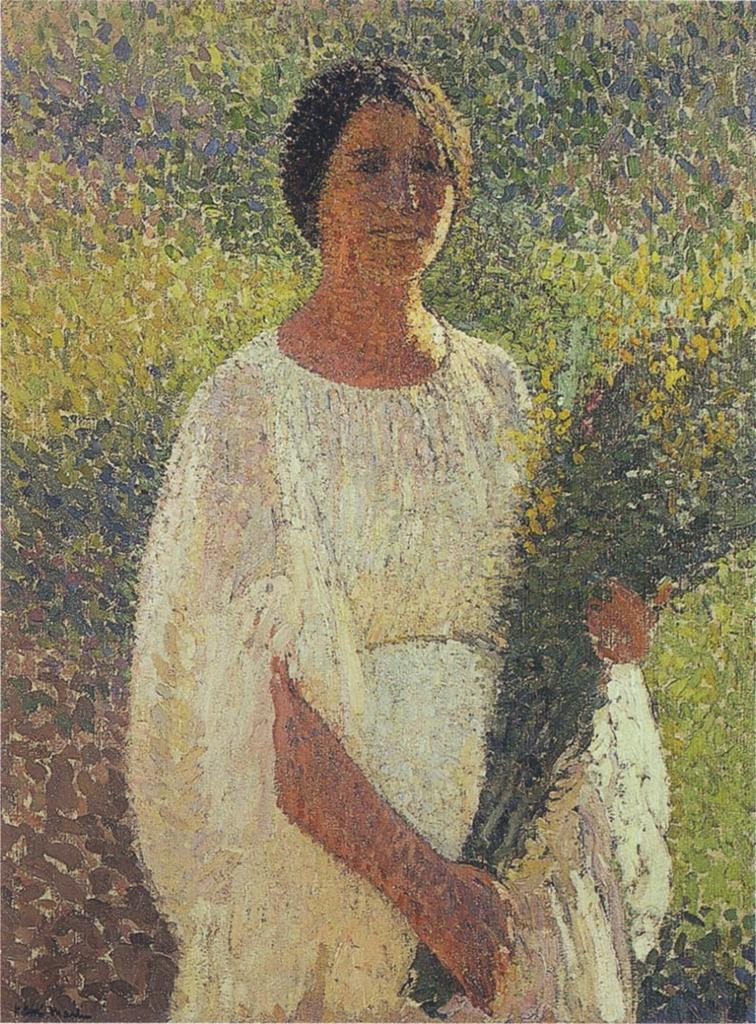What is the woman in the image doing? The woman is standing in the image and holding flowers in her hands. What might the woman be planning to do with the flowers? The woman might be planning to give the flowers to someone or arrange them in a vase. What can be seen behind the woman in the image? There are plants visible behind the woman in the image. What type of cheese is the woman holding in the image? The woman is not holding cheese in the image; she is holding flowers. 